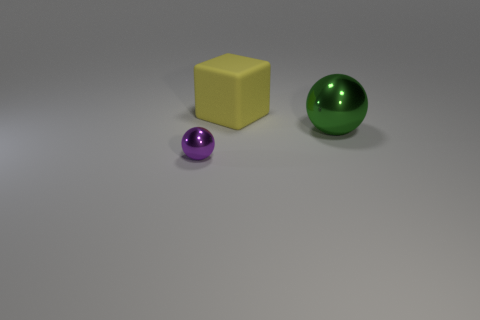Are there any other things that are made of the same material as the big yellow block?
Give a very brief answer. No. What color is the other tiny thing that is made of the same material as the green object?
Ensure brevity in your answer.  Purple. There is a tiny purple thing; is its shape the same as the large object behind the large green metal thing?
Provide a succinct answer. No. There is a purple object; are there any large matte blocks on the left side of it?
Provide a succinct answer. No. Do the green metallic object and the object behind the big ball have the same size?
Provide a short and direct response. Yes. Is there a big metal ball of the same color as the large rubber thing?
Make the answer very short. No. Is there a big green object that has the same shape as the small shiny object?
Ensure brevity in your answer.  Yes. What shape is the object that is left of the big green sphere and behind the tiny purple metallic ball?
Offer a terse response. Cube. How many purple things have the same material as the green object?
Offer a very short reply. 1. Is the number of large green shiny balls that are in front of the yellow matte thing less than the number of tiny metal blocks?
Offer a terse response. No. 